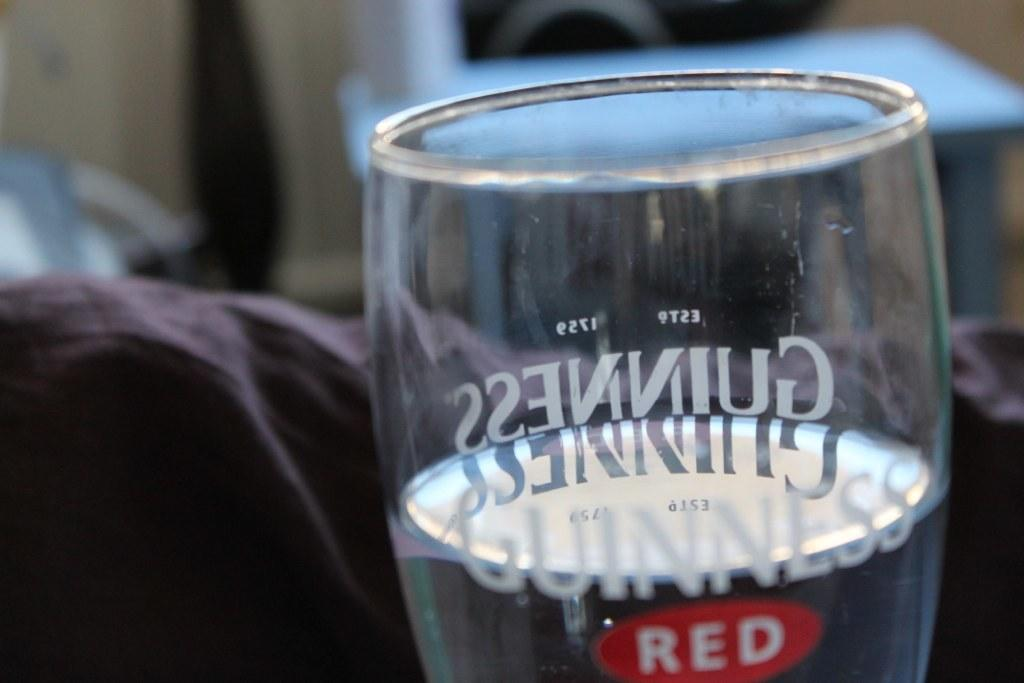What is the main object in the center of the image? There is a glass in the center of the image. What is inside the glass? There is liquid in the glass. Is there any writing or design on the glass? Yes, there is text on the glass. What else can be seen in the image besides the glass? There are other objects visible in the background of the image. How does the sheep feel about the verse written on the glass in the image? There is no sheep present in the image, so it is impossible to determine how it might feel about any verse written on the glass. 